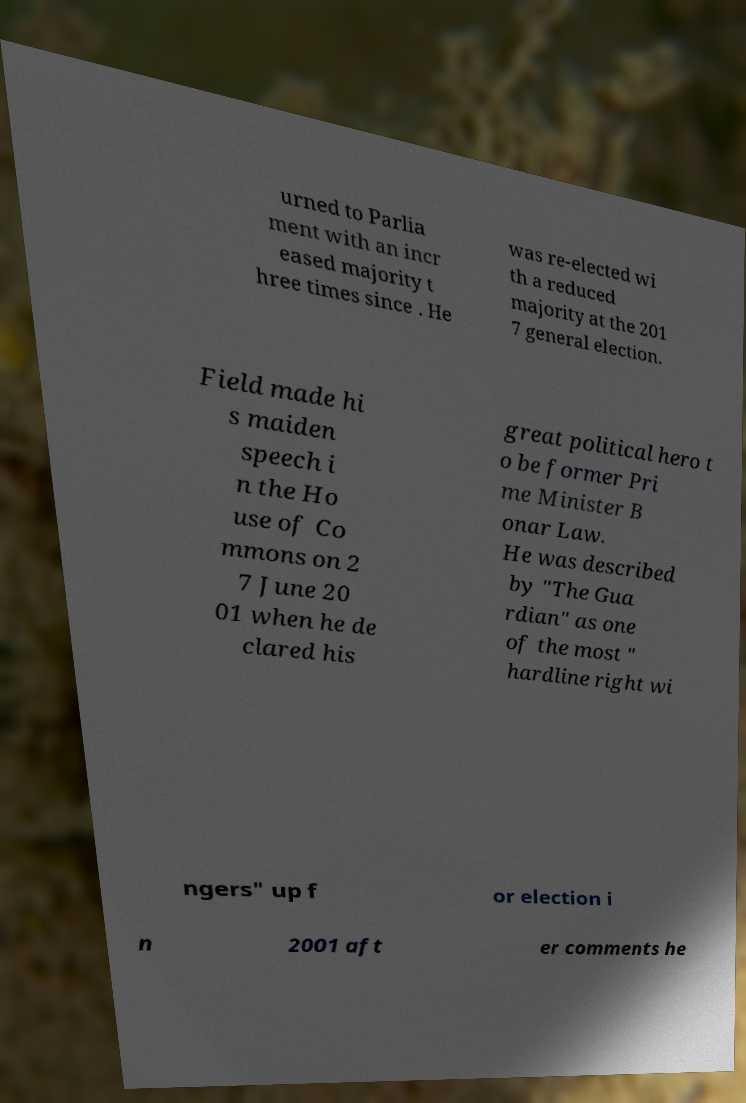What messages or text are displayed in this image? I need them in a readable, typed format. urned to Parlia ment with an incr eased majority t hree times since . He was re-elected wi th a reduced majority at the 201 7 general election. Field made hi s maiden speech i n the Ho use of Co mmons on 2 7 June 20 01 when he de clared his great political hero t o be former Pri me Minister B onar Law. He was described by "The Gua rdian" as one of the most " hardline right wi ngers" up f or election i n 2001 aft er comments he 